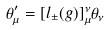Convert formula to latex. <formula><loc_0><loc_0><loc_500><loc_500>\theta _ { \mu } ^ { \prime } = [ l _ { \pm } ( g ) ] _ { \mu } ^ { \nu } \theta _ { \nu }</formula> 